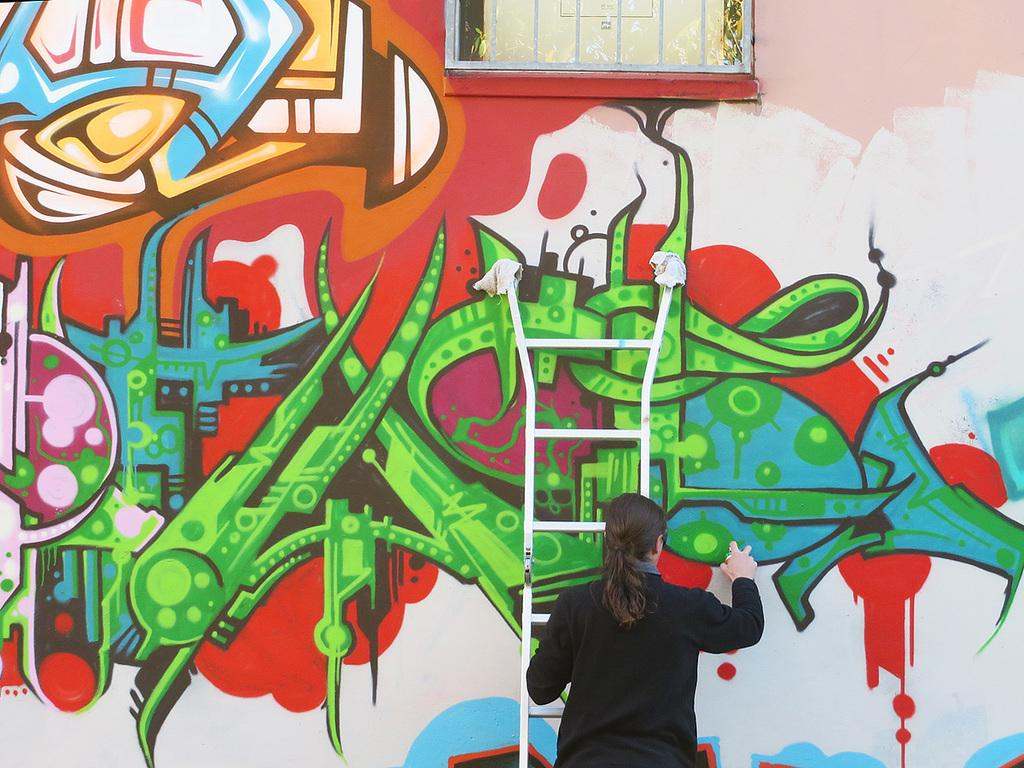Who is the main subject in the foreground of the image? There is a woman in the foreground of the image. What is the woman doing in the image? The woman is on a ladder and doing graffiti painting on a wall. What type of lunch is the woman eating while painting the graffiti? There is no indication in the image that the woman is eating lunch, so it cannot be determined from the picture. 